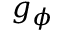Convert formula to latex. <formula><loc_0><loc_0><loc_500><loc_500>g _ { \phi }</formula> 